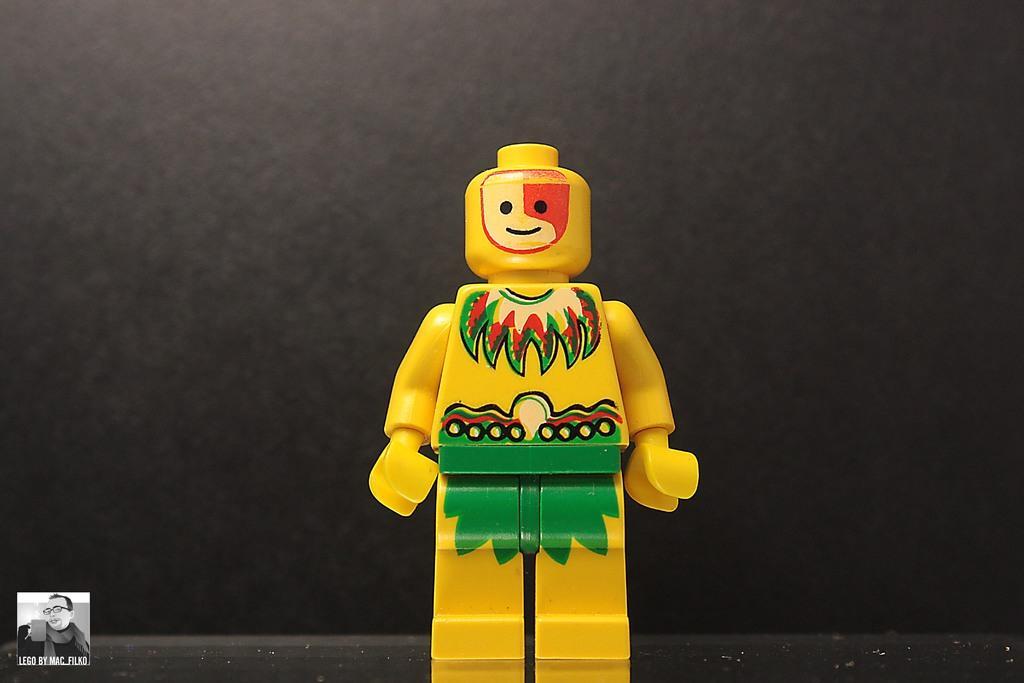Can you describe this image briefly? In this image we can see a toy, there is a picture and text on the image, and the background is gray in color. 